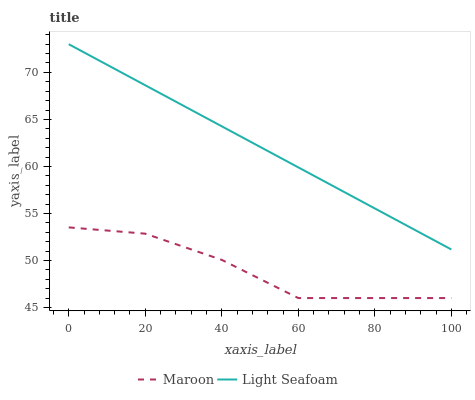Does Maroon have the minimum area under the curve?
Answer yes or no. Yes. Does Light Seafoam have the maximum area under the curve?
Answer yes or no. Yes. Does Maroon have the maximum area under the curve?
Answer yes or no. No. Is Light Seafoam the smoothest?
Answer yes or no. Yes. Is Maroon the roughest?
Answer yes or no. Yes. Is Maroon the smoothest?
Answer yes or no. No. Does Light Seafoam have the highest value?
Answer yes or no. Yes. Does Maroon have the highest value?
Answer yes or no. No. Is Maroon less than Light Seafoam?
Answer yes or no. Yes. Is Light Seafoam greater than Maroon?
Answer yes or no. Yes. Does Maroon intersect Light Seafoam?
Answer yes or no. No. 